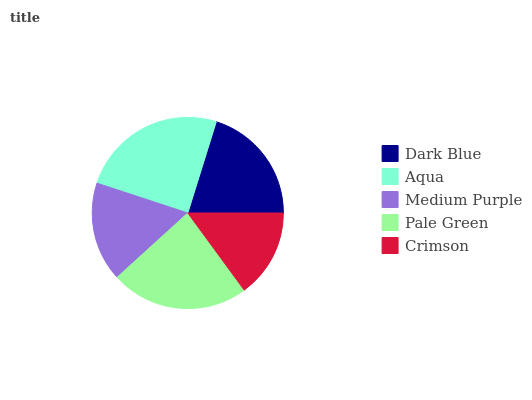Is Crimson the minimum?
Answer yes or no. Yes. Is Aqua the maximum?
Answer yes or no. Yes. Is Medium Purple the minimum?
Answer yes or no. No. Is Medium Purple the maximum?
Answer yes or no. No. Is Aqua greater than Medium Purple?
Answer yes or no. Yes. Is Medium Purple less than Aqua?
Answer yes or no. Yes. Is Medium Purple greater than Aqua?
Answer yes or no. No. Is Aqua less than Medium Purple?
Answer yes or no. No. Is Dark Blue the high median?
Answer yes or no. Yes. Is Dark Blue the low median?
Answer yes or no. Yes. Is Pale Green the high median?
Answer yes or no. No. Is Crimson the low median?
Answer yes or no. No. 